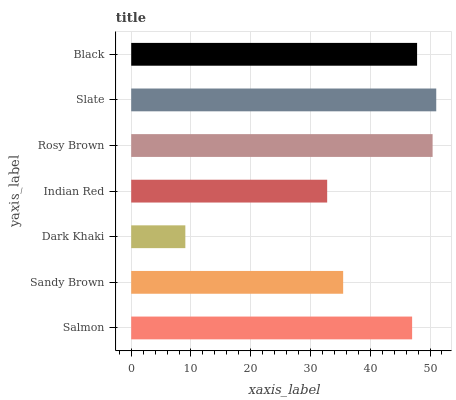Is Dark Khaki the minimum?
Answer yes or no. Yes. Is Slate the maximum?
Answer yes or no. Yes. Is Sandy Brown the minimum?
Answer yes or no. No. Is Sandy Brown the maximum?
Answer yes or no. No. Is Salmon greater than Sandy Brown?
Answer yes or no. Yes. Is Sandy Brown less than Salmon?
Answer yes or no. Yes. Is Sandy Brown greater than Salmon?
Answer yes or no. No. Is Salmon less than Sandy Brown?
Answer yes or no. No. Is Salmon the high median?
Answer yes or no. Yes. Is Salmon the low median?
Answer yes or no. Yes. Is Dark Khaki the high median?
Answer yes or no. No. Is Rosy Brown the low median?
Answer yes or no. No. 